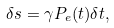Convert formula to latex. <formula><loc_0><loc_0><loc_500><loc_500>\delta s = \gamma P _ { e } ( t ) \delta t ,</formula> 